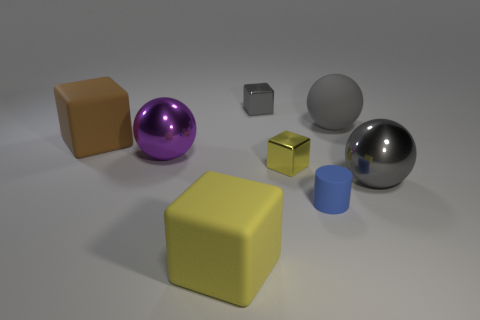Subtract all brown cylinders. How many yellow cubes are left? 2 Subtract all gray cubes. How many cubes are left? 3 Subtract all metal balls. How many balls are left? 1 Add 1 matte things. How many objects exist? 9 Subtract all green cubes. Subtract all green balls. How many cubes are left? 4 Subtract all big spheres. Subtract all large brown cubes. How many objects are left? 4 Add 5 big gray things. How many big gray things are left? 7 Add 3 big things. How many big things exist? 8 Subtract 0 blue cubes. How many objects are left? 8 Subtract all cylinders. How many objects are left? 7 